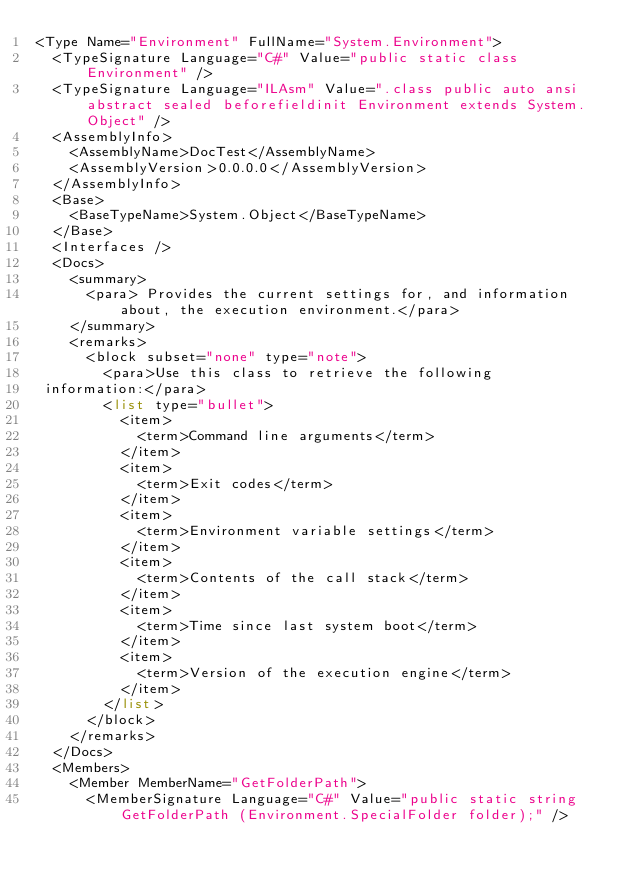Convert code to text. <code><loc_0><loc_0><loc_500><loc_500><_XML_><Type Name="Environment" FullName="System.Environment">
  <TypeSignature Language="C#" Value="public static class Environment" />
  <TypeSignature Language="ILAsm" Value=".class public auto ansi abstract sealed beforefieldinit Environment extends System.Object" />
  <AssemblyInfo>
    <AssemblyName>DocTest</AssemblyName>
    <AssemblyVersion>0.0.0.0</AssemblyVersion>
  </AssemblyInfo>
  <Base>
    <BaseTypeName>System.Object</BaseTypeName>
  </Base>
  <Interfaces />
  <Docs>
    <summary>
      <para> Provides the current settings for, and information about, the execution environment.</para>
    </summary>
    <remarks>
      <block subset="none" type="note">
        <para>Use this class to retrieve the following 
 information:</para>
        <list type="bullet">
          <item>
            <term>Command line arguments</term>
          </item>
          <item>
            <term>Exit codes</term>
          </item>
          <item>
            <term>Environment variable settings</term>
          </item>
          <item>
            <term>Contents of the call stack</term>
          </item>
          <item>
            <term>Time since last system boot</term>
          </item>
          <item>
            <term>Version of the execution engine</term>
          </item>
        </list>
      </block>
    </remarks>
  </Docs>
  <Members>
    <Member MemberName="GetFolderPath">
      <MemberSignature Language="C#" Value="public static string GetFolderPath (Environment.SpecialFolder folder);" /></code> 